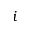<formula> <loc_0><loc_0><loc_500><loc_500>i</formula> 